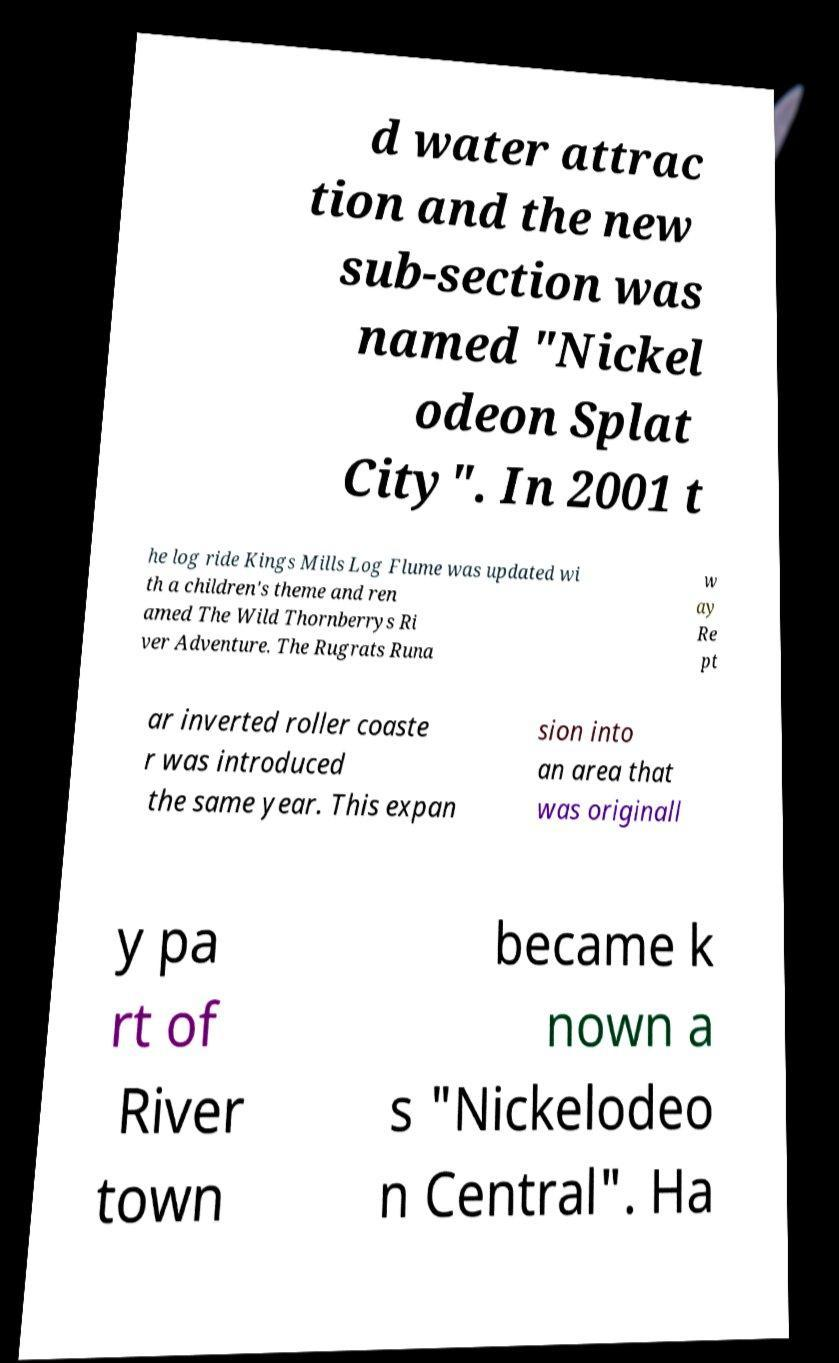Could you extract and type out the text from this image? d water attrac tion and the new sub-section was named "Nickel odeon Splat City". In 2001 t he log ride Kings Mills Log Flume was updated wi th a children's theme and ren amed The Wild Thornberrys Ri ver Adventure. The Rugrats Runa w ay Re pt ar inverted roller coaste r was introduced the same year. This expan sion into an area that was originall y pa rt of River town became k nown a s "Nickelodeo n Central". Ha 